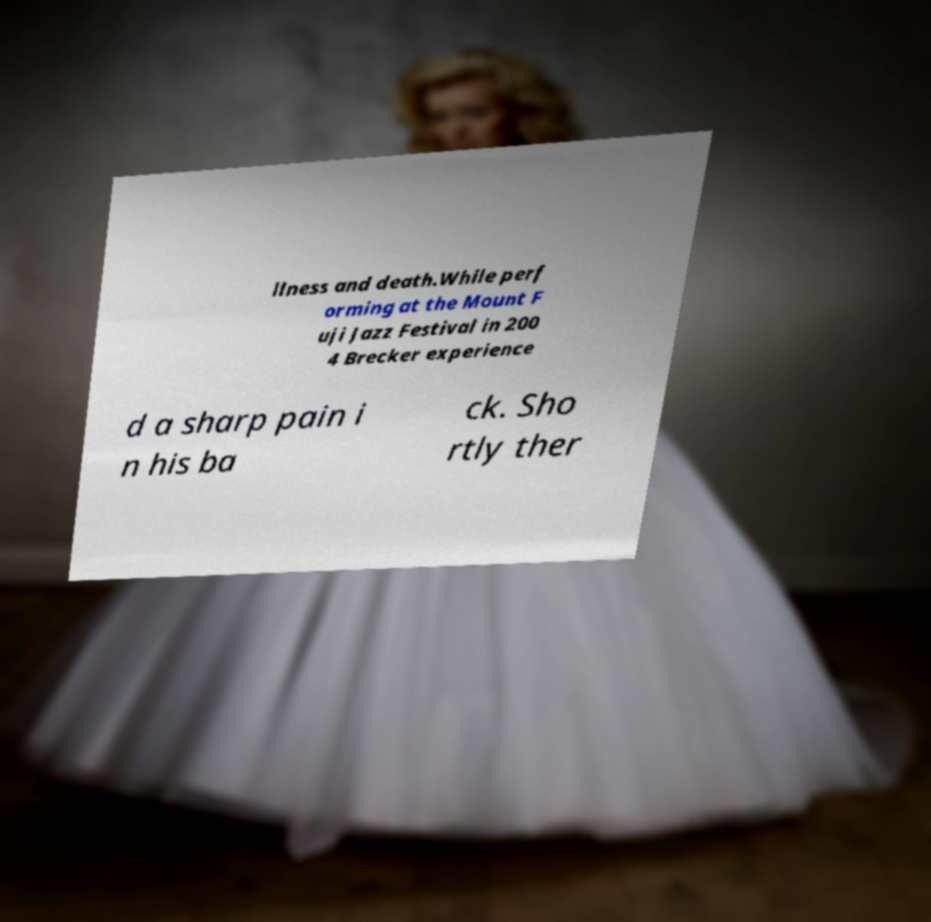What messages or text are displayed in this image? I need them in a readable, typed format. llness and death.While perf orming at the Mount F uji Jazz Festival in 200 4 Brecker experience d a sharp pain i n his ba ck. Sho rtly ther 